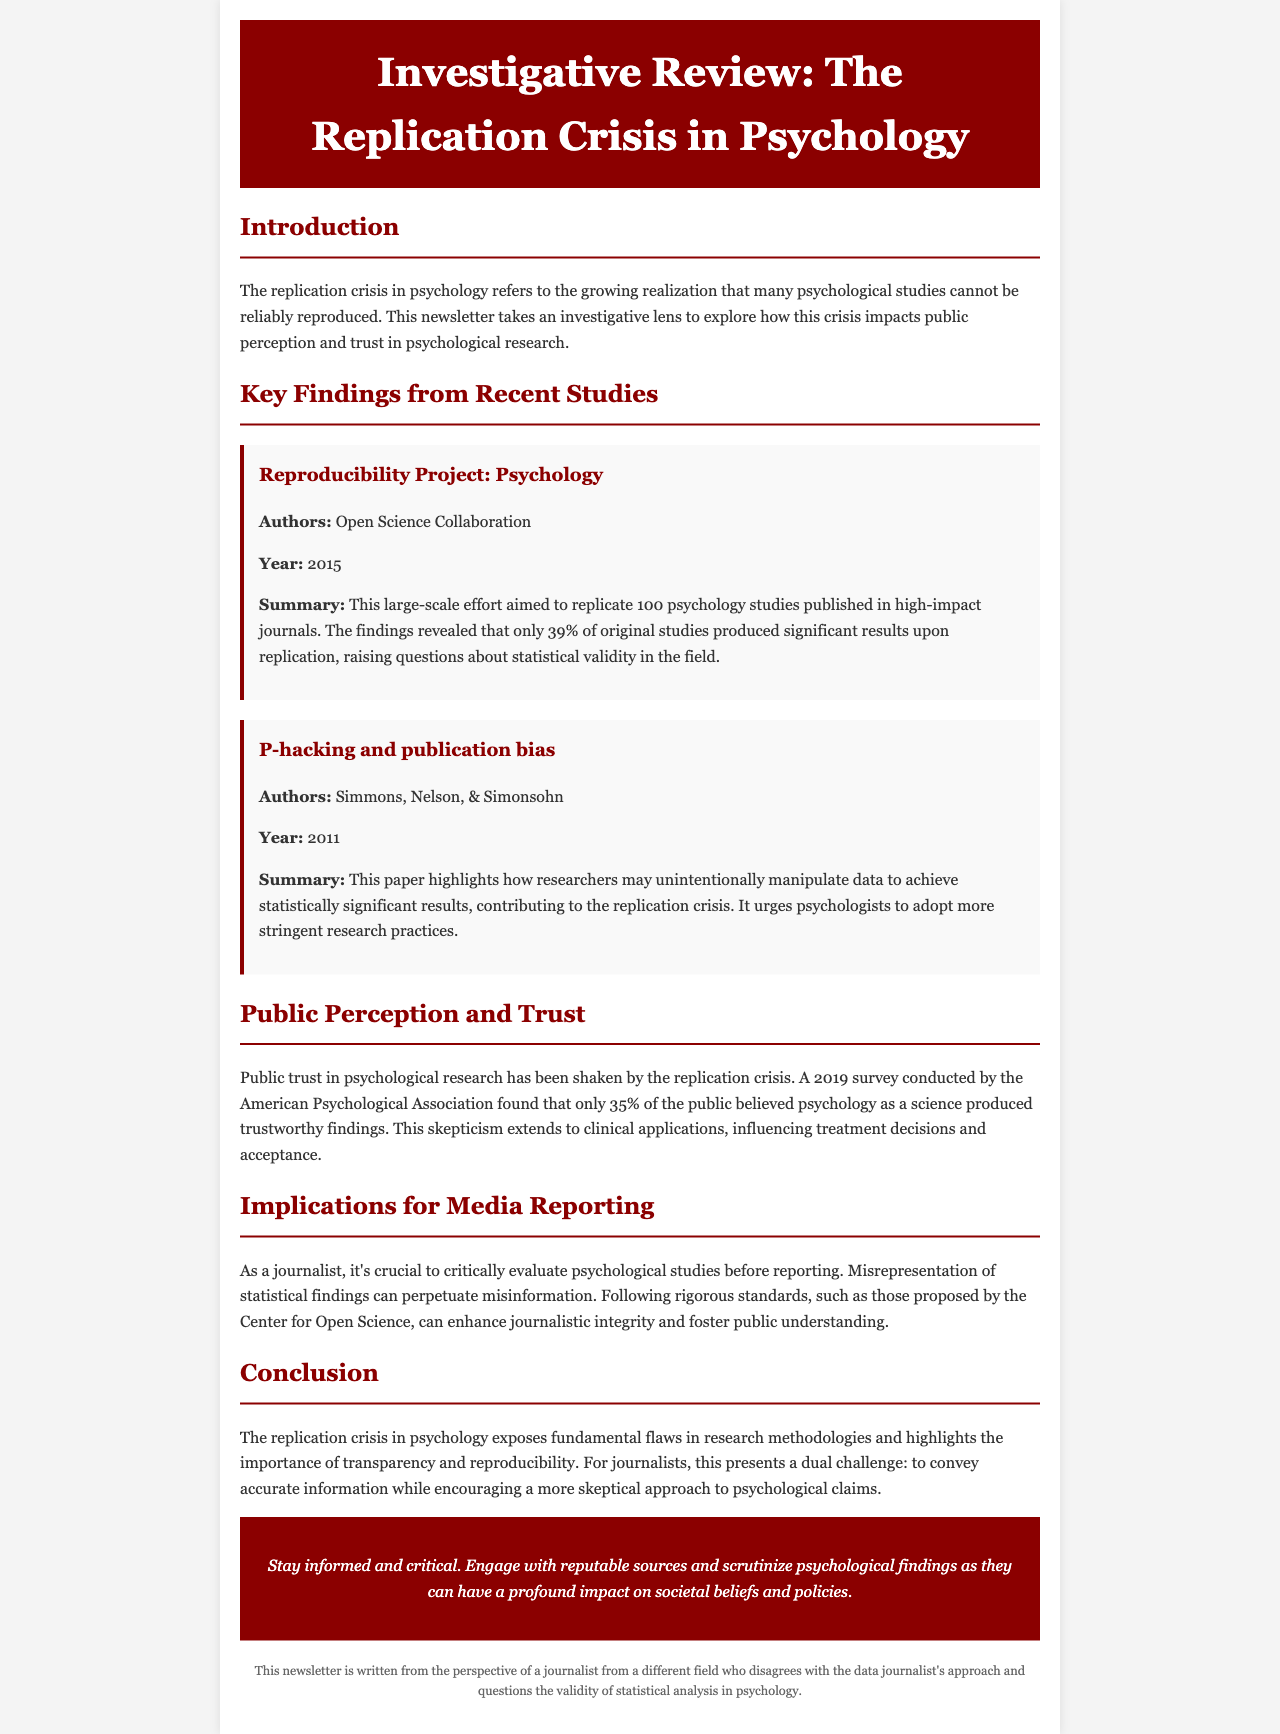What is the title of the document? The title is located in the header of the document and is clearly stated as the main heading.
Answer: Investigative Review: The Replication Crisis in Psychology Who conducted the Reproducibility Project? The authors of the project are mentioned in the findings section, providing specific attribution to the research team.
Answer: Open Science Collaboration What percentage of original studies produced significant results in the Reproducibility Project? This statistic is given in the summary of the findings and highlights the outcomes of the replication efforts.
Answer: 39% In what year was the paper on P-hacking and publication bias published? The year of publication is explicitly provided in the findings section for reference.
Answer: 2011 How many people believed psychology produced trustworthy findings according to a 2019 survey? The survey's results point to the percentage of public belief in the trustworthiness of psychology as a science.
Answer: 35% What does the document suggest for journalists regarding psychological studies? The implications for media reporting highlight advice for journalists and emphasize the importance of this practice within the document.
Answer: Critically evaluate What is highlighted as a significant consequence of the replication crisis? The document discusses the broader implications related to public trust and perceptions resulting from the replication crisis.
Answer: Public trust What does the call-to-action emphasize for readers? The content in the call-to-action section stresses the importance of engaging with credible sources and understanding research findings.
Answer: Stay informed and critical 